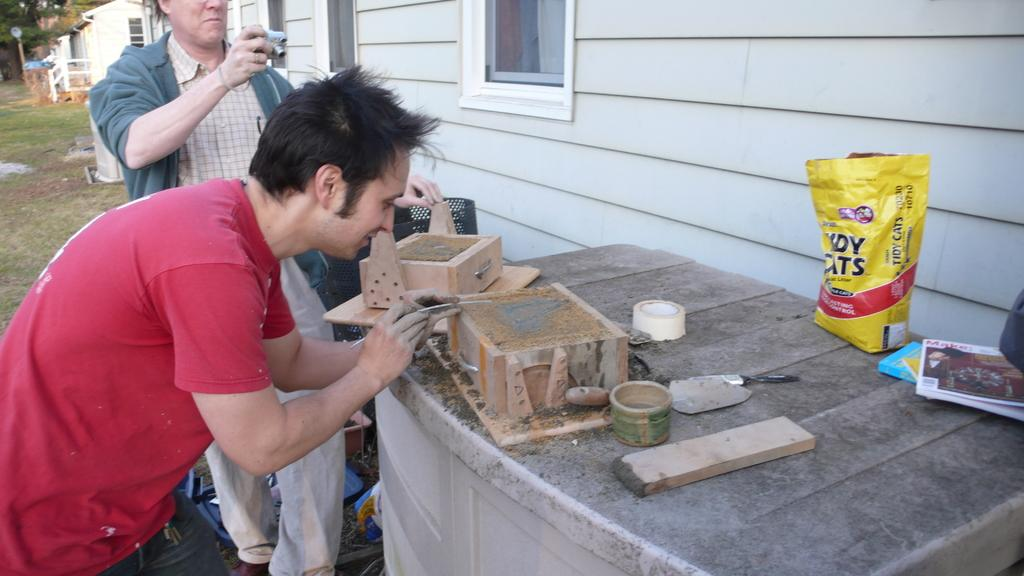What is present in the image that might be used for packaging or sealing? There is a packet and tape in the image. What items can be seen in the image that might be used for reading or learning? There are books in the image. What type of objects made of wood can be seen in the image? There are wooden objects in the image. What device is present in the image that might be used for capturing images or videos? There is a camera in the image. What type of structures are visible in the image? There are houses in the image. What architectural feature can be seen in the houses? There are windows in the houses. What type of natural environment is visible in the image? There is grass visible in the image. How many people are present in the image? There are two people standing in the image. What type of vegetation can be seen in the background of the image? There are trees in the background of the image. What type of knee injury can be seen in the image? There is no knee injury present in the image. What type of plate is being used by the people in the image? There is no plate visible in the image. What type of animal can be seen in the image? There are no animals present in the image. 